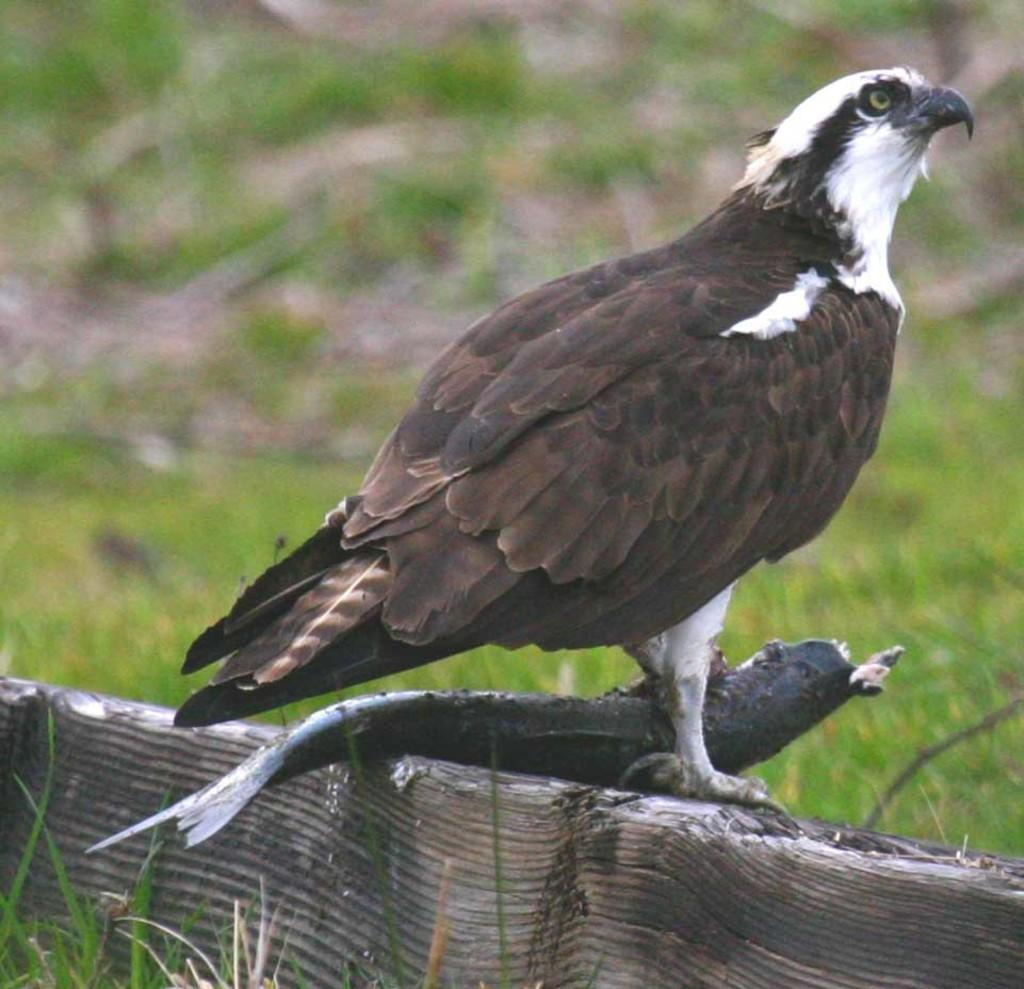What type of animal can be seen in the image? There is a bird in the image. What is the bird holding in its beak? The bird is holding a fish. Where is the bird standing? The bird is standing on a wall. What color is the background of the image? The background of the image is green. What type of coal is visible in the image? There is no coal present in the image. Can you tell me the species of the wren in the image? There is no wren present in the image; it is a bird holding a fish. 